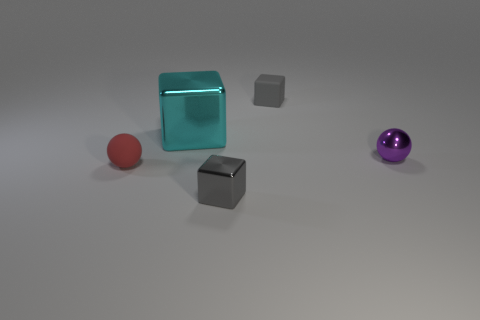Subtract all brown balls. How many gray blocks are left? 2 Subtract all tiny gray blocks. How many blocks are left? 1 Add 5 small cyan cylinders. How many objects exist? 10 Subtract 0 blue cylinders. How many objects are left? 5 Subtract all spheres. How many objects are left? 3 Subtract all matte spheres. Subtract all matte balls. How many objects are left? 3 Add 1 tiny red balls. How many tiny red balls are left? 2 Add 5 large cyan shiny blocks. How many large cyan shiny blocks exist? 6 